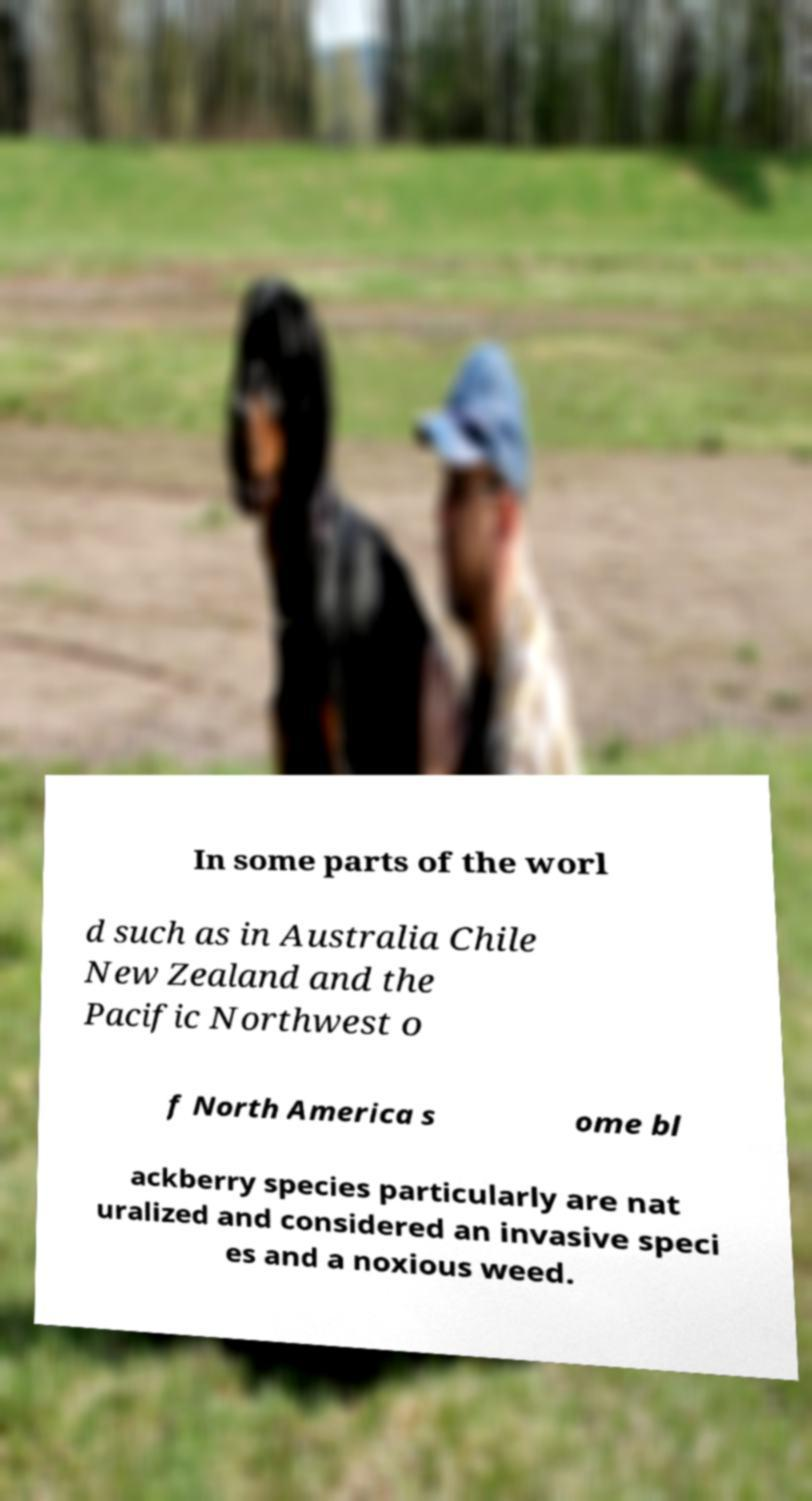Can you accurately transcribe the text from the provided image for me? In some parts of the worl d such as in Australia Chile New Zealand and the Pacific Northwest o f North America s ome bl ackberry species particularly are nat uralized and considered an invasive speci es and a noxious weed. 